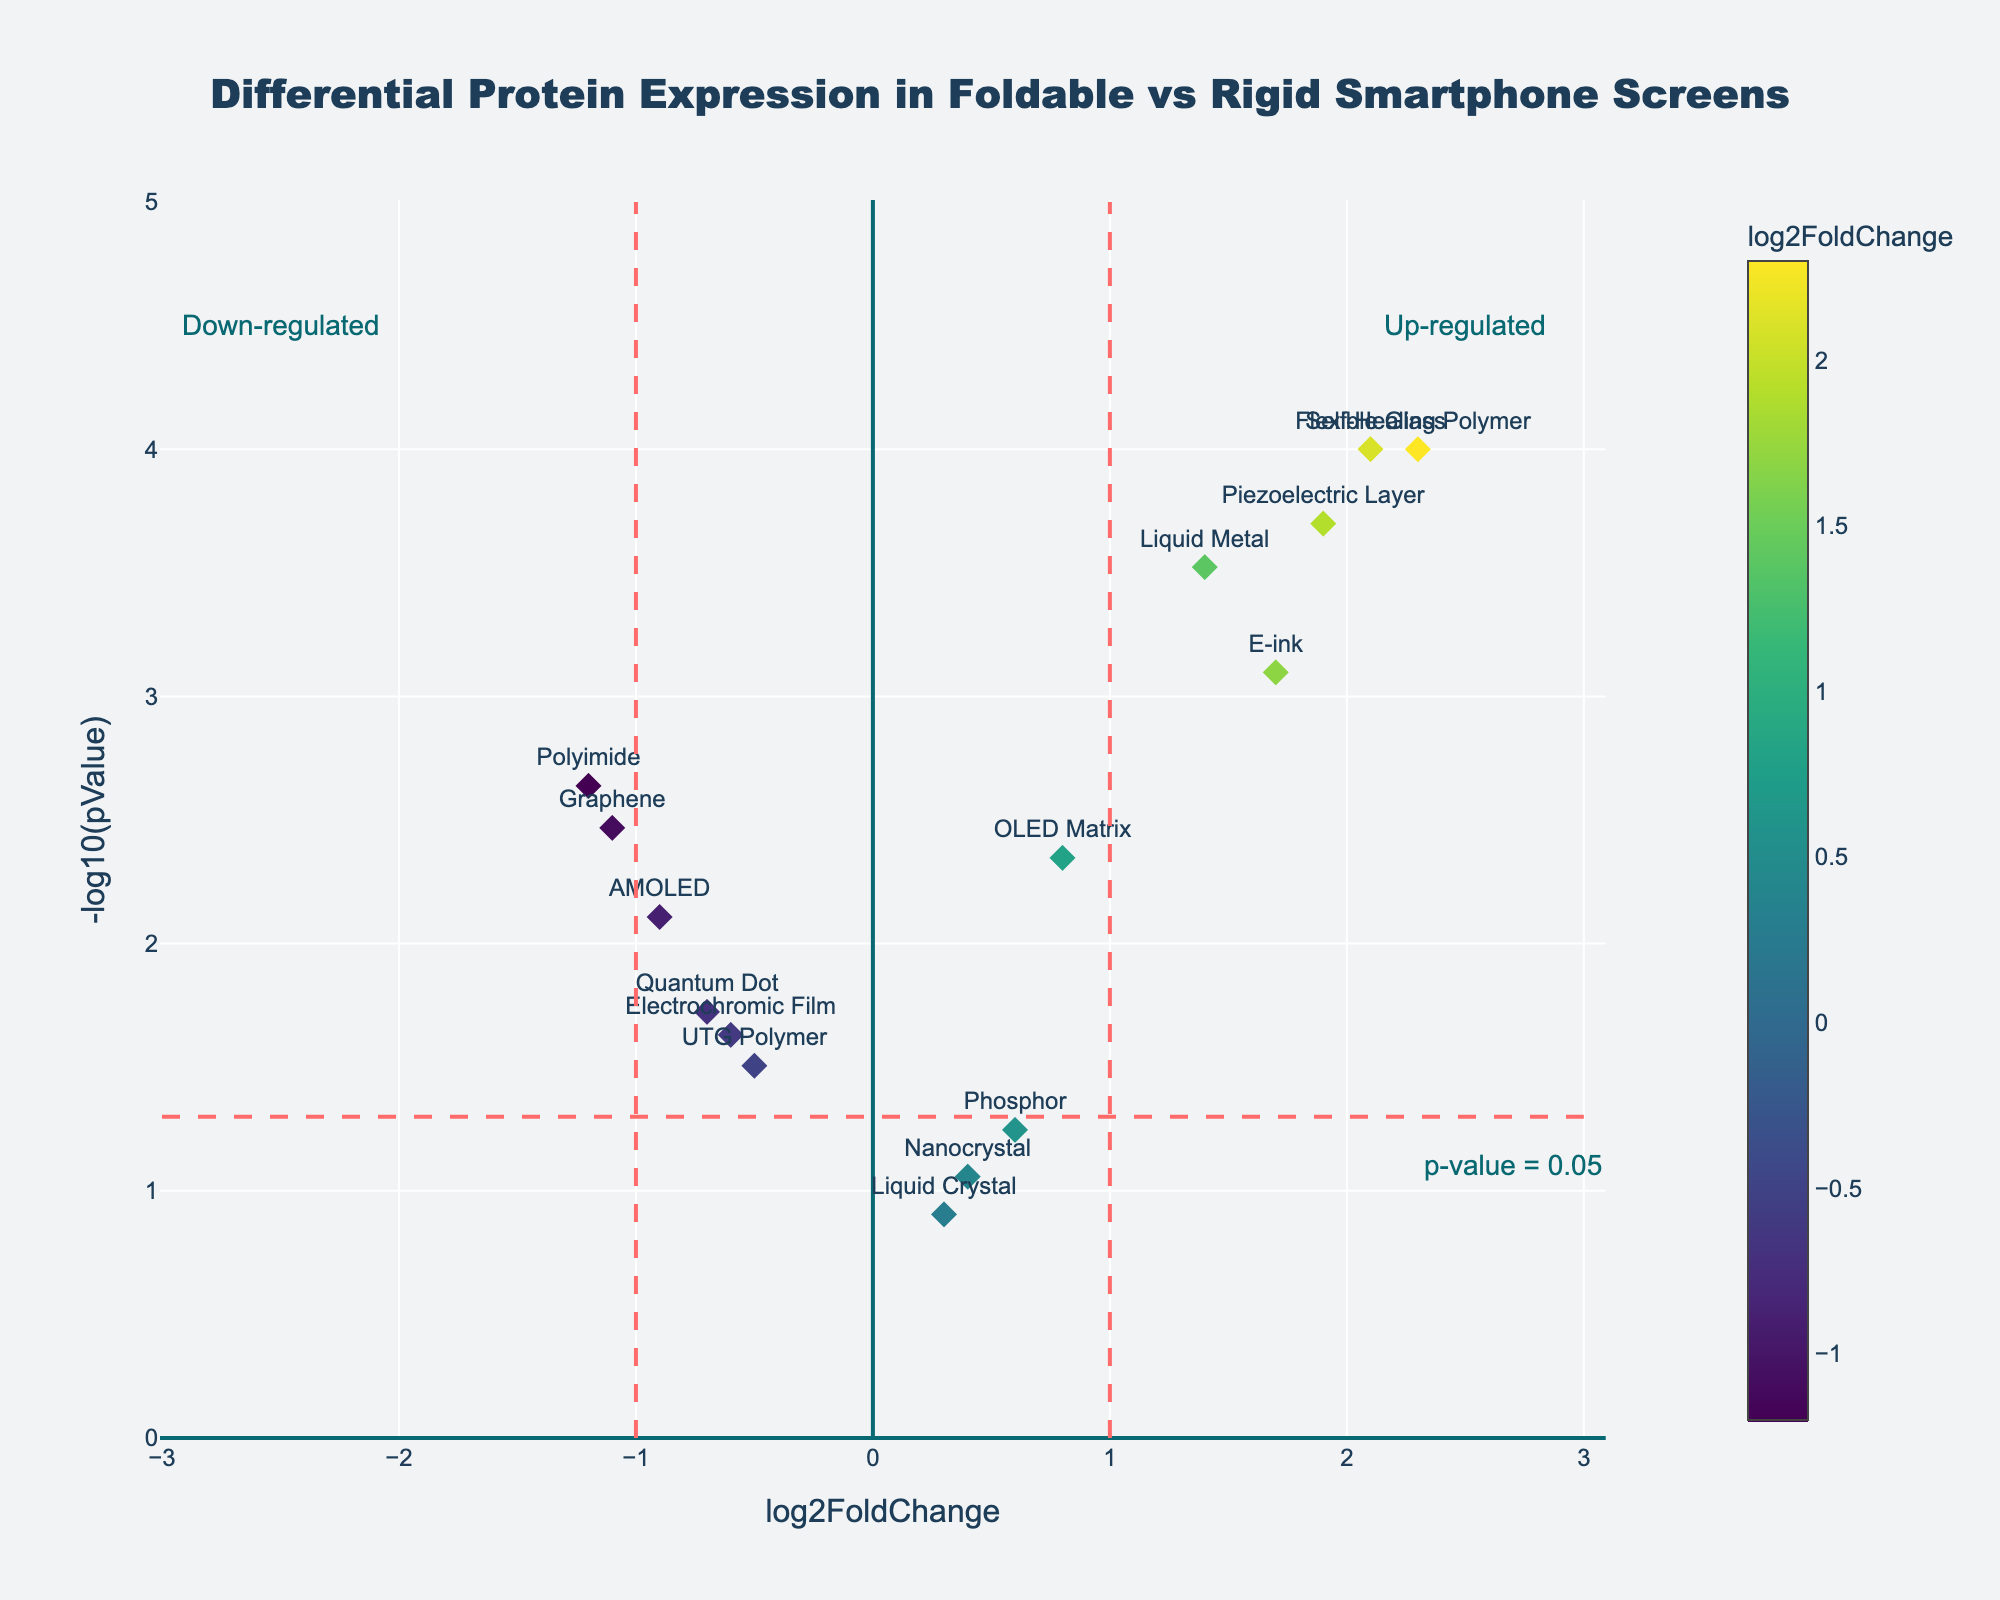What is the title of the figure? The title is located at the top center of the figure, usually in larger, bold text. It summarizes what the figure is about.
Answer: Differential Protein Expression in Foldable vs Rigid Smartphone Screens How many proteins have a log2FoldChange greater than 1? Identify and count the data points on the plot that appear to the right of the vertical line at log2FoldChange = 1.
Answer: 5 Which protein shows the highest up-regulation in terms of log2FoldChange? Look for the data point with the highest positive value on the x-axis.
Answer: Self-Healing Polymer What does a higher value on the y-axis (-log10(pValue)) indicate? Higher values on the y-axis indicate lower p-values, meaning stronger statistical significance.
Answer: Stronger statistical significance Which proteins are considered significantly up-regulated? Proteins with log2FoldChange > 1 and -log10(pValue) > 1.3 (equivalent to p-value < 0.05) are considered significantly up-regulated.
Answer: Flexible Glass, E-ink, Liquid Metal, Piezoelectric Layer, Self-Healing Polymer What does the horizontal dashed line represent? The horizontal dashed line at -log10(pValue) = 1.3 represents the threshold for significance, equivalent to a pValue of 0.05.
Answer: p-value = 0.05 threshold Which protein has the lowest p-value? Identify the protein with the highest y-value in the plot.
Answer: Flexible Glass and Self-Healing Polymer How many proteins fall within the non-significant range (p-value > 0.05)? Count the data points that are below the horizontal dashed line, indicating a p-value greater than 0.05.
Answer: 5 What is the color of the data points representing down-regulated proteins? Down-regulated proteins are those to the left of log2FoldChange = -1 and they are colored darker on the Viridis color scale used.
Answer: Darker colors (e.g., shades of blue and green) Which protein shows slight up-regulation but is not statistically significant? Identify the protein with a small positive log2FoldChange value and a -log10(pValue) below 1.3.
Answer: Liquid Crystal 